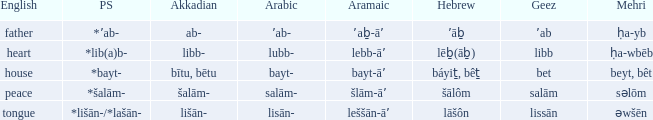If the aramaic is šlām-āʼ, what is the english? Peace. 